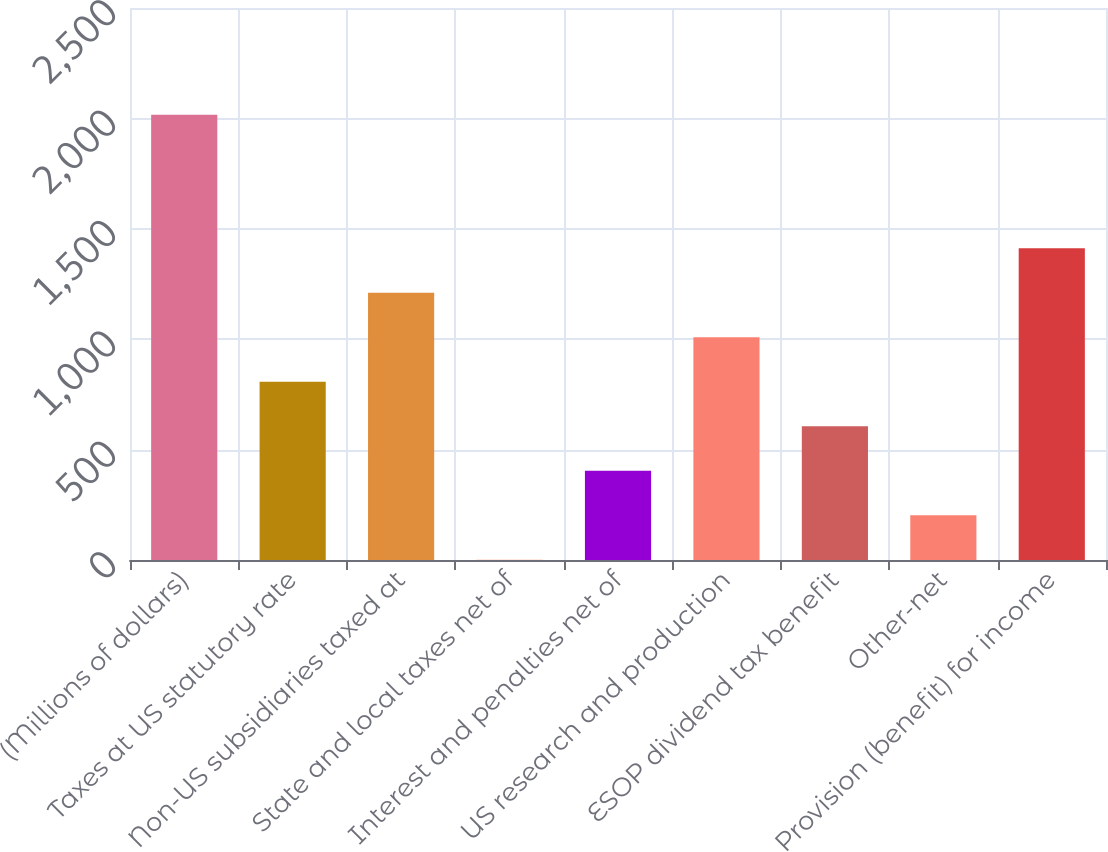<chart> <loc_0><loc_0><loc_500><loc_500><bar_chart><fcel>(Millions of dollars)<fcel>Taxes at US statutory rate<fcel>Non-US subsidiaries taxed at<fcel>State and local taxes net of<fcel>Interest and penalties net of<fcel>US research and production<fcel>ESOP dividend tax benefit<fcel>Other-net<fcel>Provision (benefit) for income<nl><fcel>2016<fcel>806.82<fcel>1209.88<fcel>0.7<fcel>403.76<fcel>1008.35<fcel>605.29<fcel>202.23<fcel>1411.41<nl></chart> 